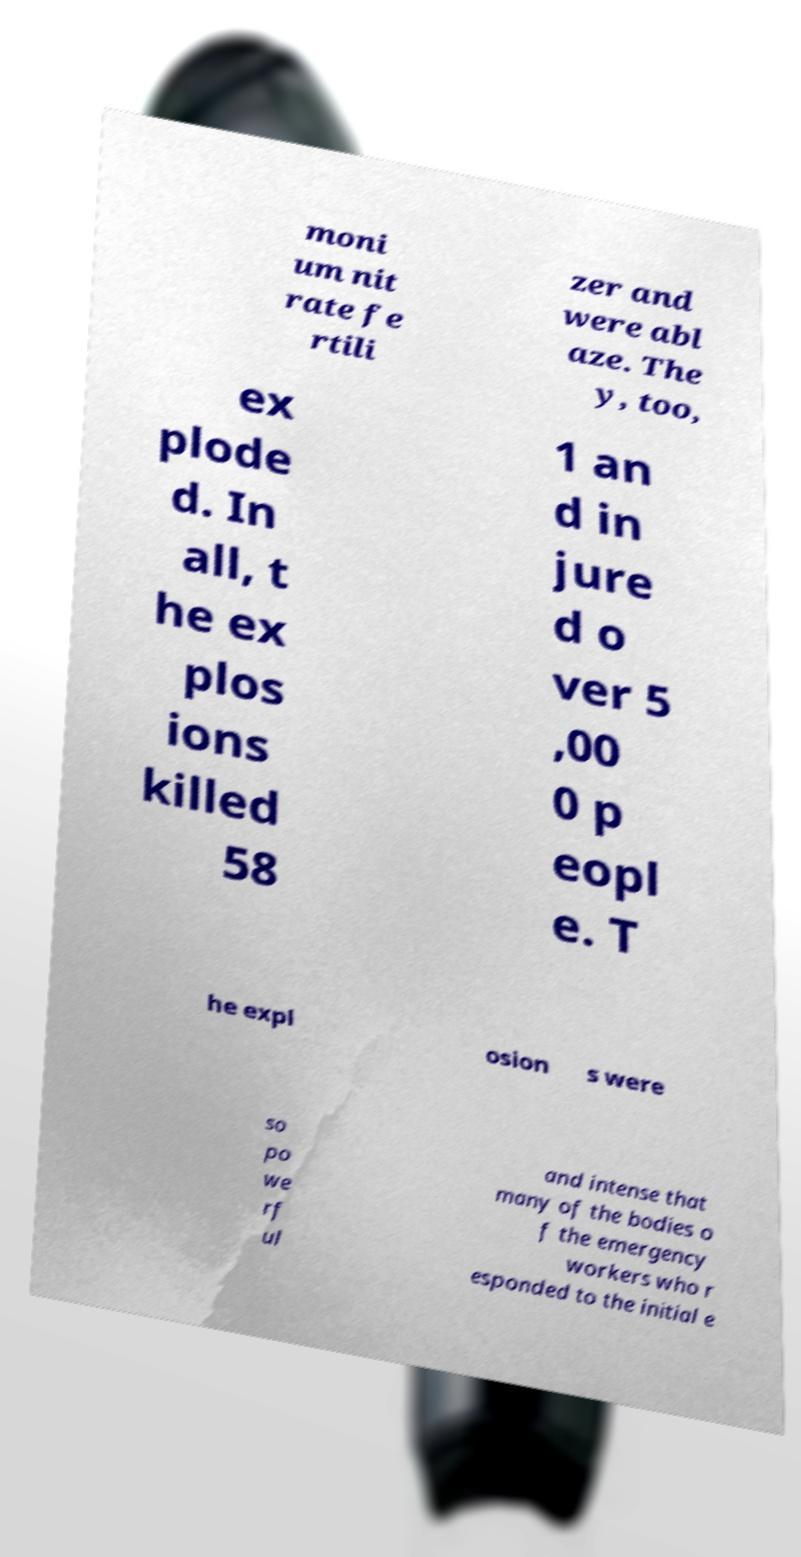There's text embedded in this image that I need extracted. Can you transcribe it verbatim? moni um nit rate fe rtili zer and were abl aze. The y, too, ex plode d. In all, t he ex plos ions killed 58 1 an d in jure d o ver 5 ,00 0 p eopl e. T he expl osion s were so po we rf ul and intense that many of the bodies o f the emergency workers who r esponded to the initial e 